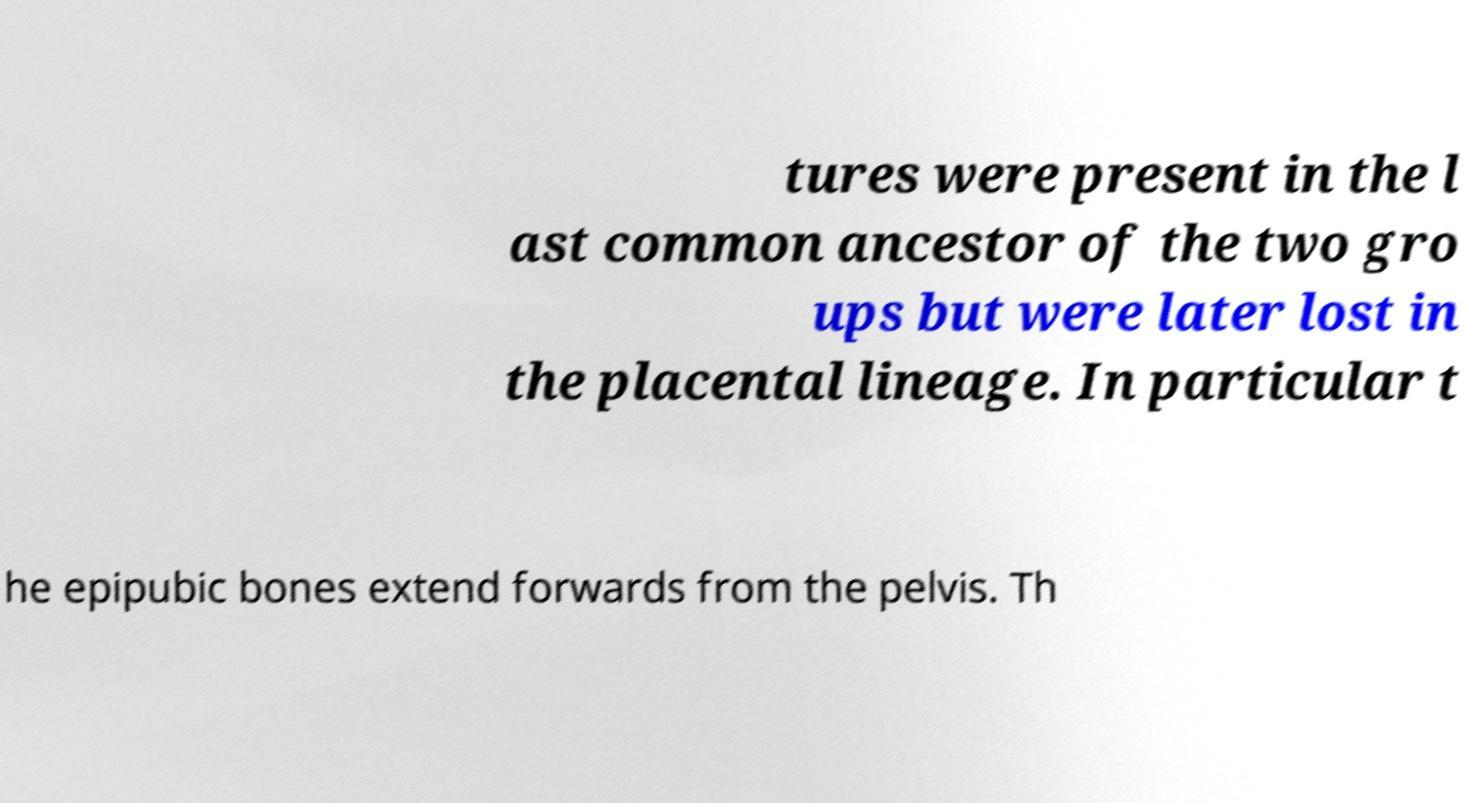Could you extract and type out the text from this image? tures were present in the l ast common ancestor of the two gro ups but were later lost in the placental lineage. In particular t he epipubic bones extend forwards from the pelvis. Th 